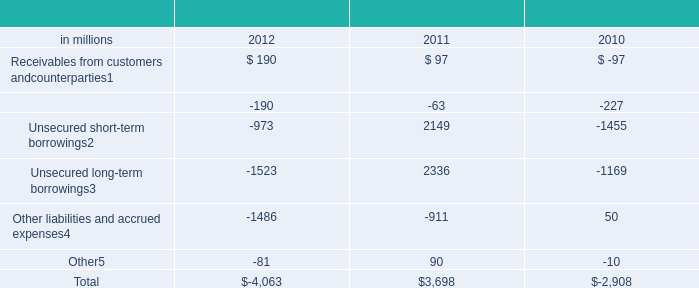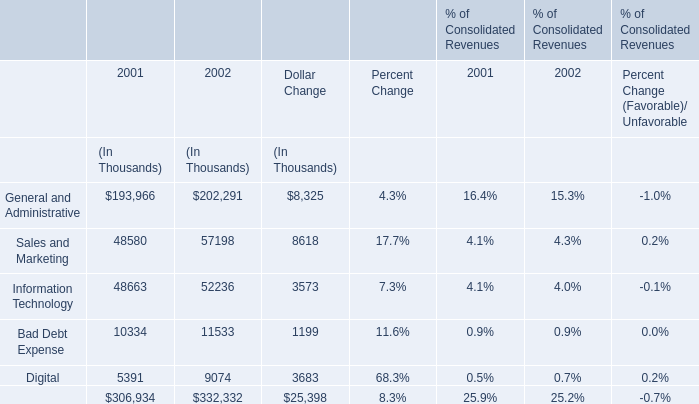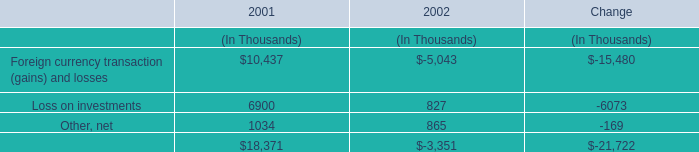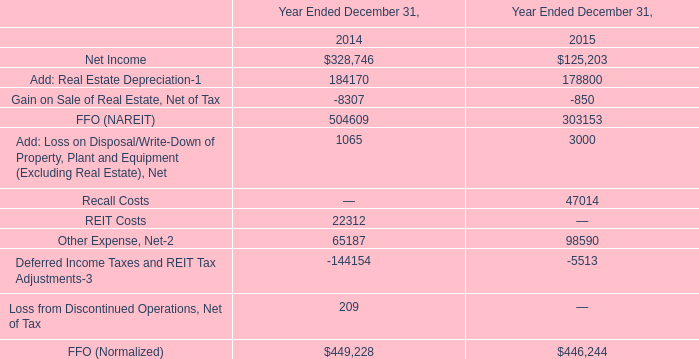What is the average value of General and Administrative in 2001 and Add: Real Estate Depreciation-1 in 2014 ?? 
Computations: ((193966 + 184170) / 2)
Answer: 189068.0. 